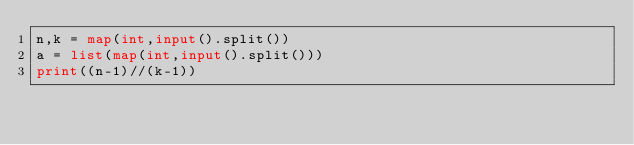Convert code to text. <code><loc_0><loc_0><loc_500><loc_500><_Python_>n,k = map(int,input().split())
a = list(map(int,input().split()))
print((n-1)//(k-1))</code> 